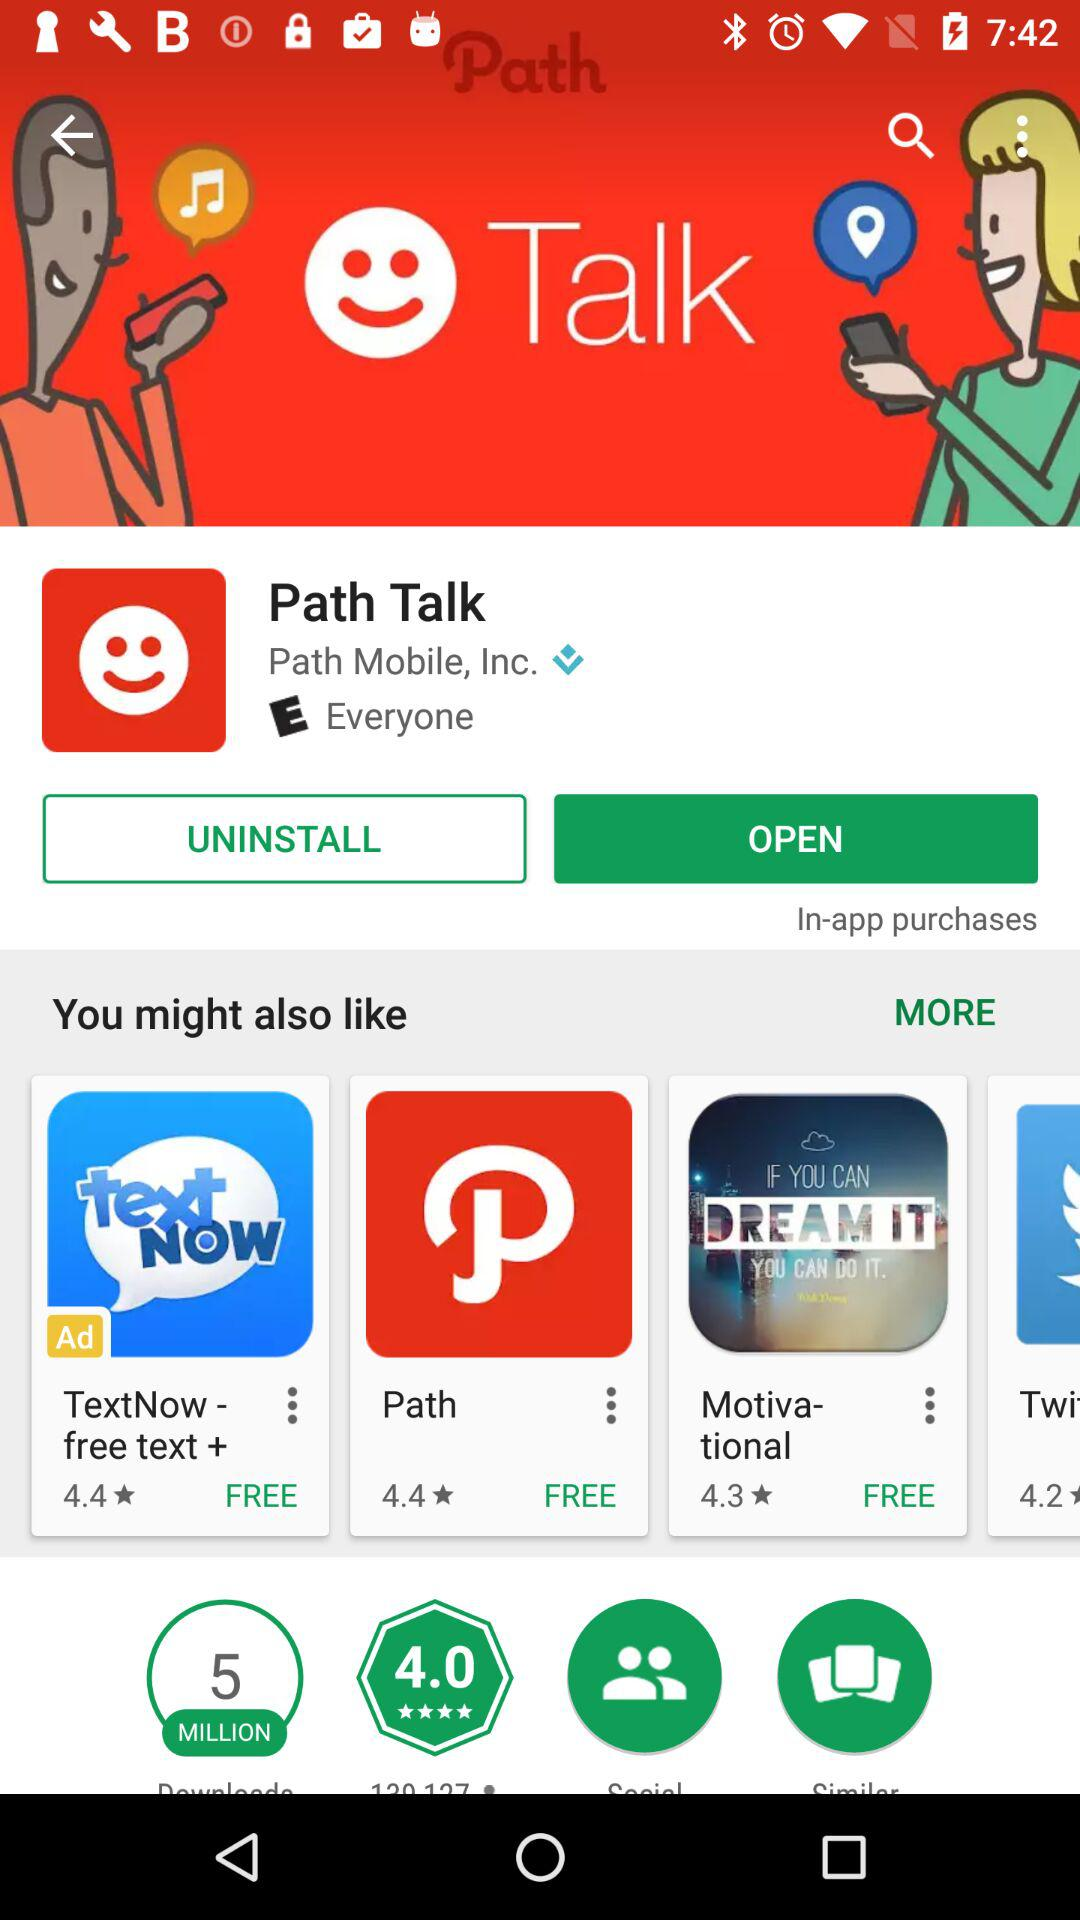What is the name of the application? The names of the applications are "Path Talk", "TextNow - free text +", "Path" and "Motivational". 